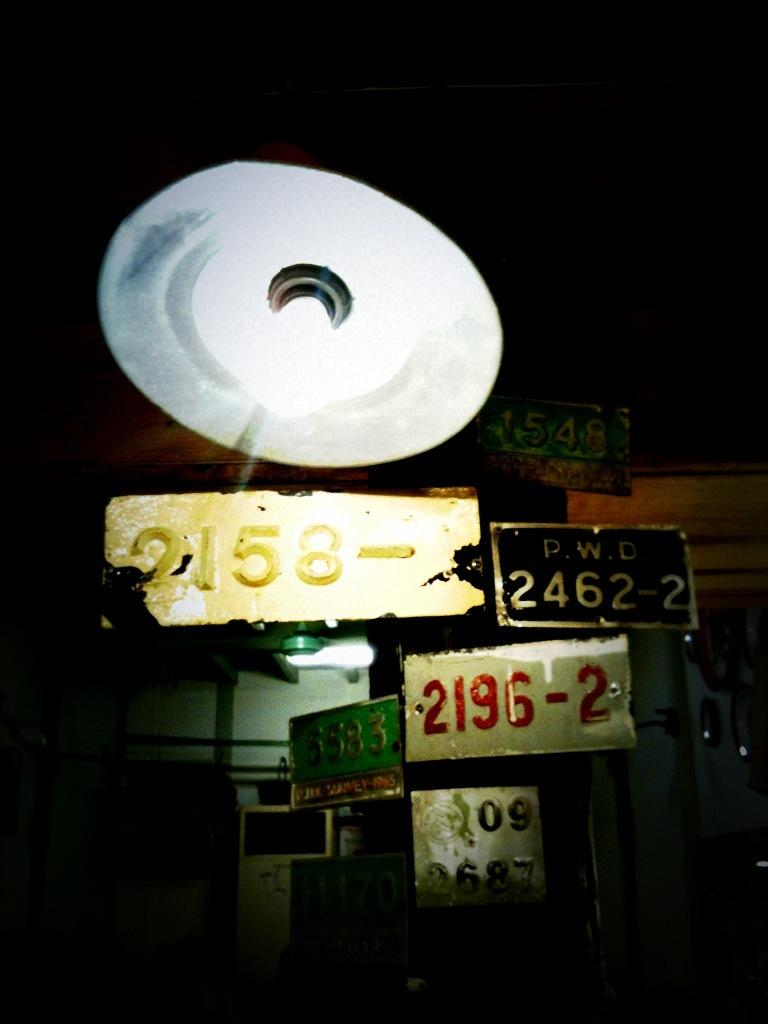What is the source of light in the image? There is a light in the image. What type of objects are made of boards in the image? The image features boards, but it does not specify what type of objects they are part of. What can be observed about the overall lighting in the image? The background of the image is dark. How many deer can be seen grazing in the image? There are no deer present in the image. What type of cakes are being served in the image? There are no cakes present in the image. 